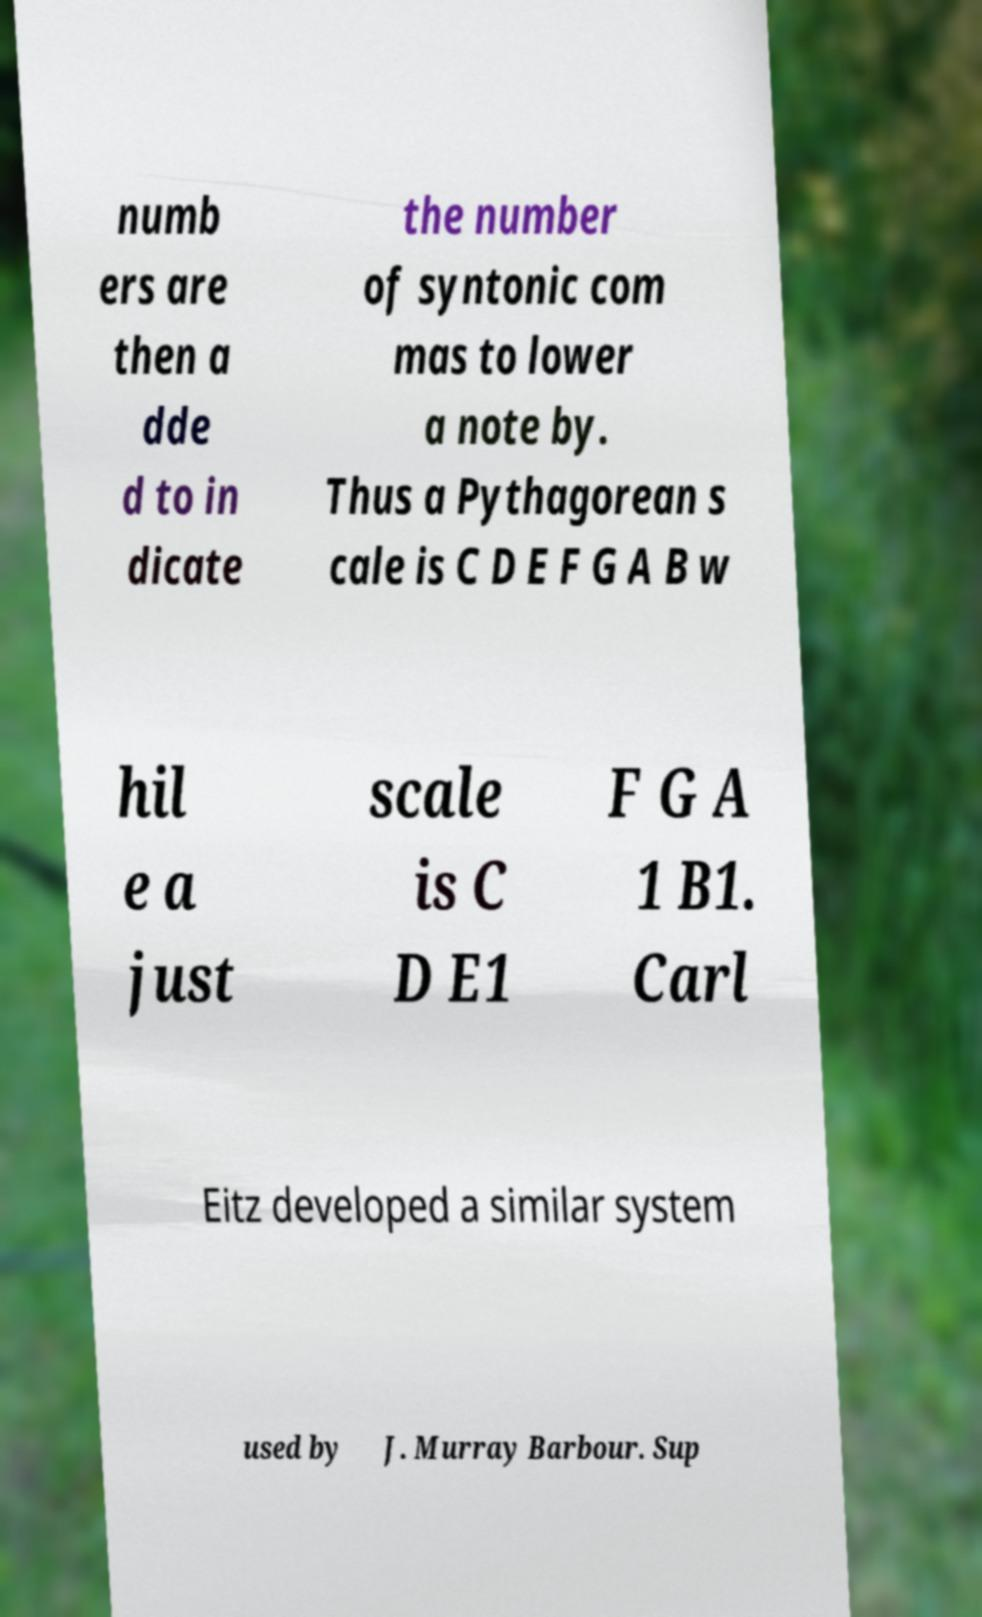Please identify and transcribe the text found in this image. numb ers are then a dde d to in dicate the number of syntonic com mas to lower a note by. Thus a Pythagorean s cale is C D E F G A B w hil e a just scale is C D E1 F G A 1 B1. Carl Eitz developed a similar system used by J. Murray Barbour. Sup 